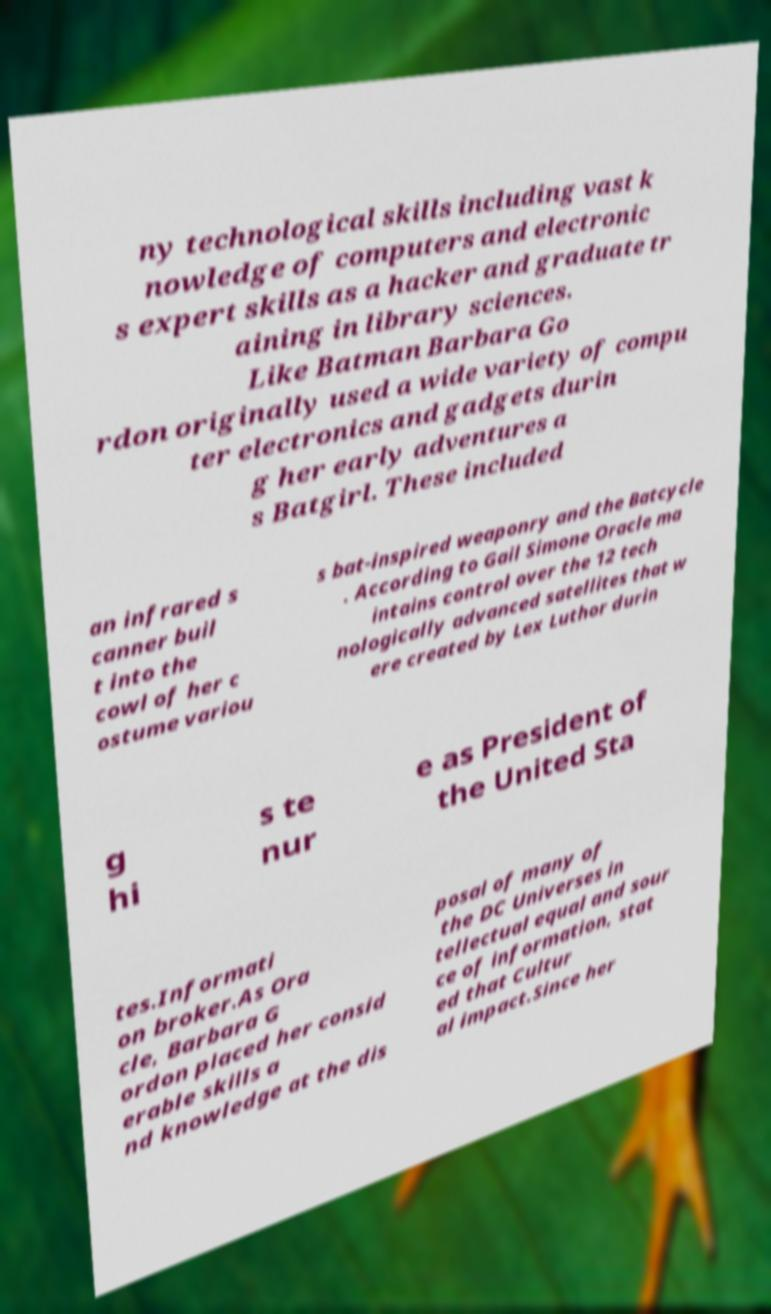I need the written content from this picture converted into text. Can you do that? ny technological skills including vast k nowledge of computers and electronic s expert skills as a hacker and graduate tr aining in library sciences. Like Batman Barbara Go rdon originally used a wide variety of compu ter electronics and gadgets durin g her early adventures a s Batgirl. These included an infrared s canner buil t into the cowl of her c ostume variou s bat-inspired weaponry and the Batcycle . According to Gail Simone Oracle ma intains control over the 12 tech nologically advanced satellites that w ere created by Lex Luthor durin g hi s te nur e as President of the United Sta tes.Informati on broker.As Ora cle, Barbara G ordon placed her consid erable skills a nd knowledge at the dis posal of many of the DC Universes in tellectual equal and sour ce of information, stat ed that Cultur al impact.Since her 